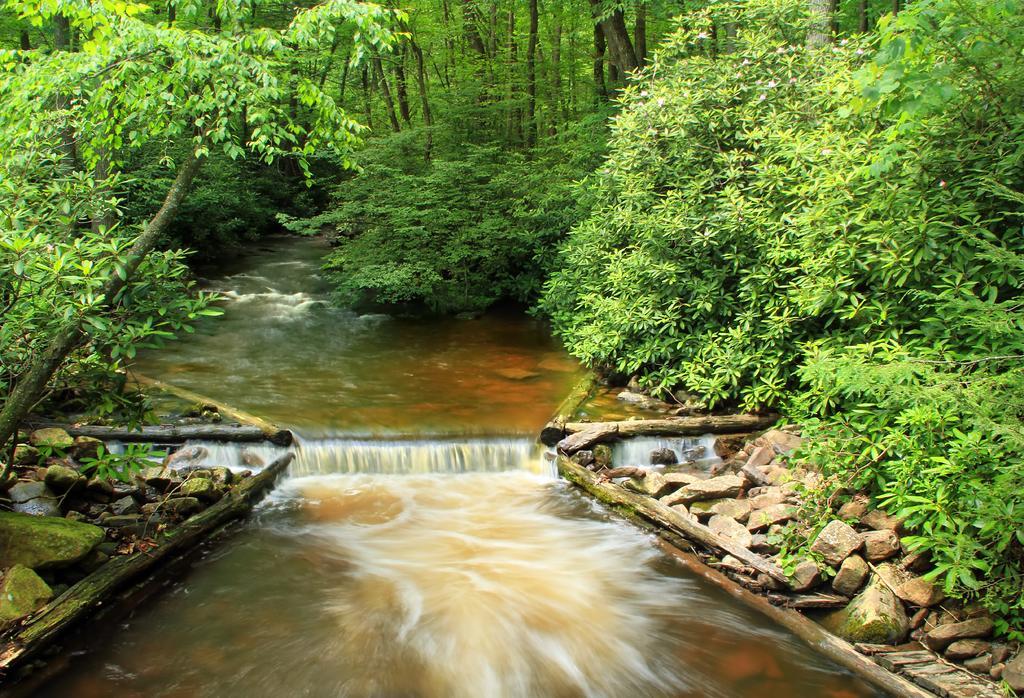Could you give a brief overview of what you see in this image? At the bottom of this image there is a river. On the right and left side of the image there are few stones. In the background there are many trees. 